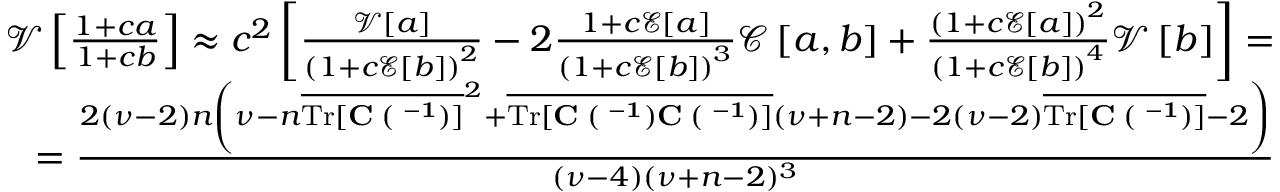Convert formula to latex. <formula><loc_0><loc_0><loc_500><loc_500>\begin{array} { r } { \mathcal { V } \left [ \frac { 1 + c a } { 1 + c b } \right ] \approx c ^ { 2 } \left [ \frac { \mathcal { V } \left [ a \right ] } { \left ( 1 + c \mathcal { E } \left [ b \right ] \right ) ^ { 2 } } - 2 \frac { 1 + c \mathcal { E } \left [ a \right ] } { \left ( 1 + c \mathcal { E } \left [ b \right ] \right ) ^ { 3 } } \mathcal { C } \left [ a , b \right ] + \frac { \left ( 1 + c \mathcal { E } \left [ a \right ] \right ) ^ { 2 } } { \left ( 1 + c \mathcal { E } \left [ b \right ] \right ) ^ { 4 } } \mathcal { V } \left [ b \right ] \right ] = } \\ { = \frac { 2 ( \nu - 2 ) n \left ( \nu - n \overline { { T r [ C \Xi ( { \Lambda } ^ { - 1 } ) ] } } ^ { 2 } + \overline { { T r [ C \Xi ( { \Lambda } ^ { - 1 } ) C \Xi ( { \Lambda } ^ { - 1 } ) ] } } ( \nu + n - 2 ) - 2 ( \nu - 2 ) \overline { { T r [ C \Xi ( { \Lambda } ^ { - 1 } ) ] } } - 2 \right ) } { ( \nu - 4 ) ( \nu + n - 2 ) ^ { 3 } } } \end{array}</formula> 